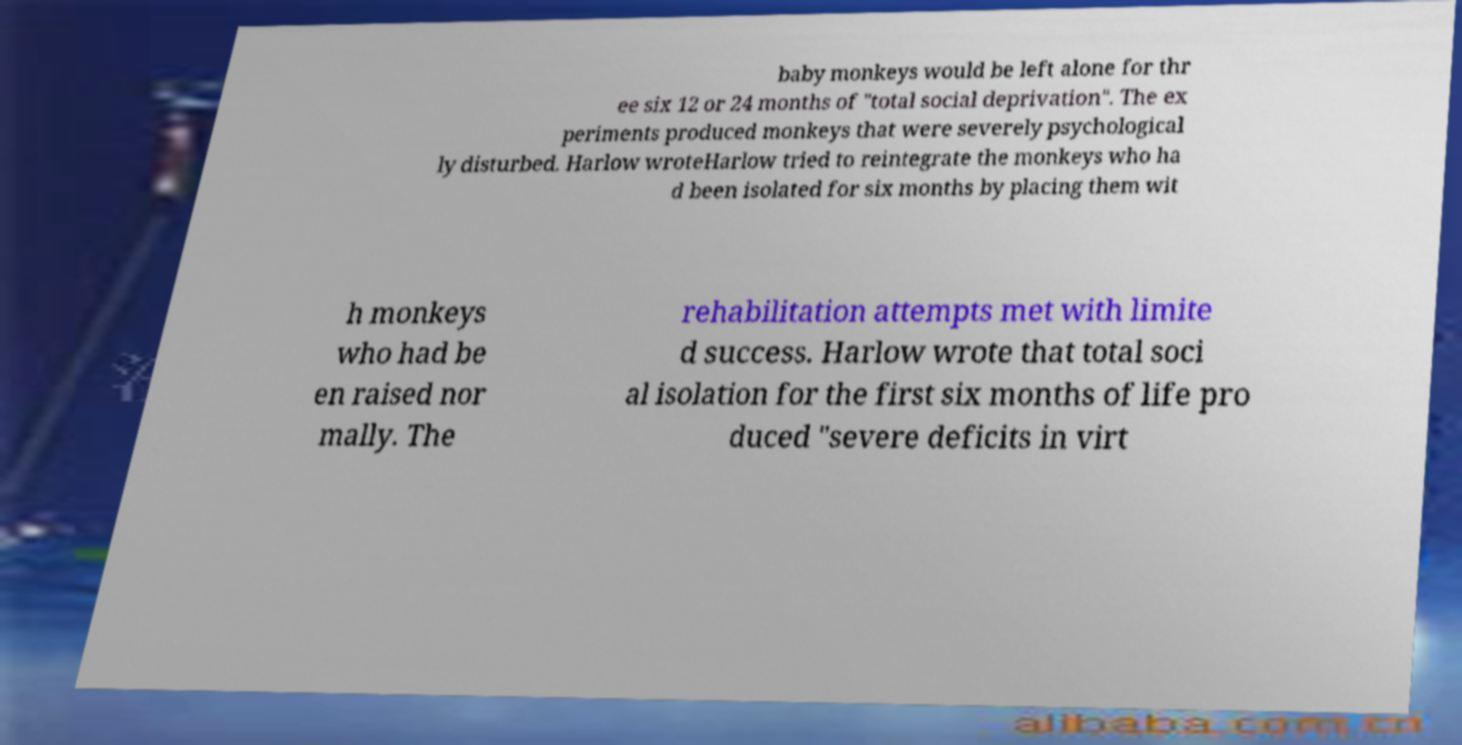Please identify and transcribe the text found in this image. baby monkeys would be left alone for thr ee six 12 or 24 months of "total social deprivation". The ex periments produced monkeys that were severely psychological ly disturbed. Harlow wroteHarlow tried to reintegrate the monkeys who ha d been isolated for six months by placing them wit h monkeys who had be en raised nor mally. The rehabilitation attempts met with limite d success. Harlow wrote that total soci al isolation for the first six months of life pro duced "severe deficits in virt 